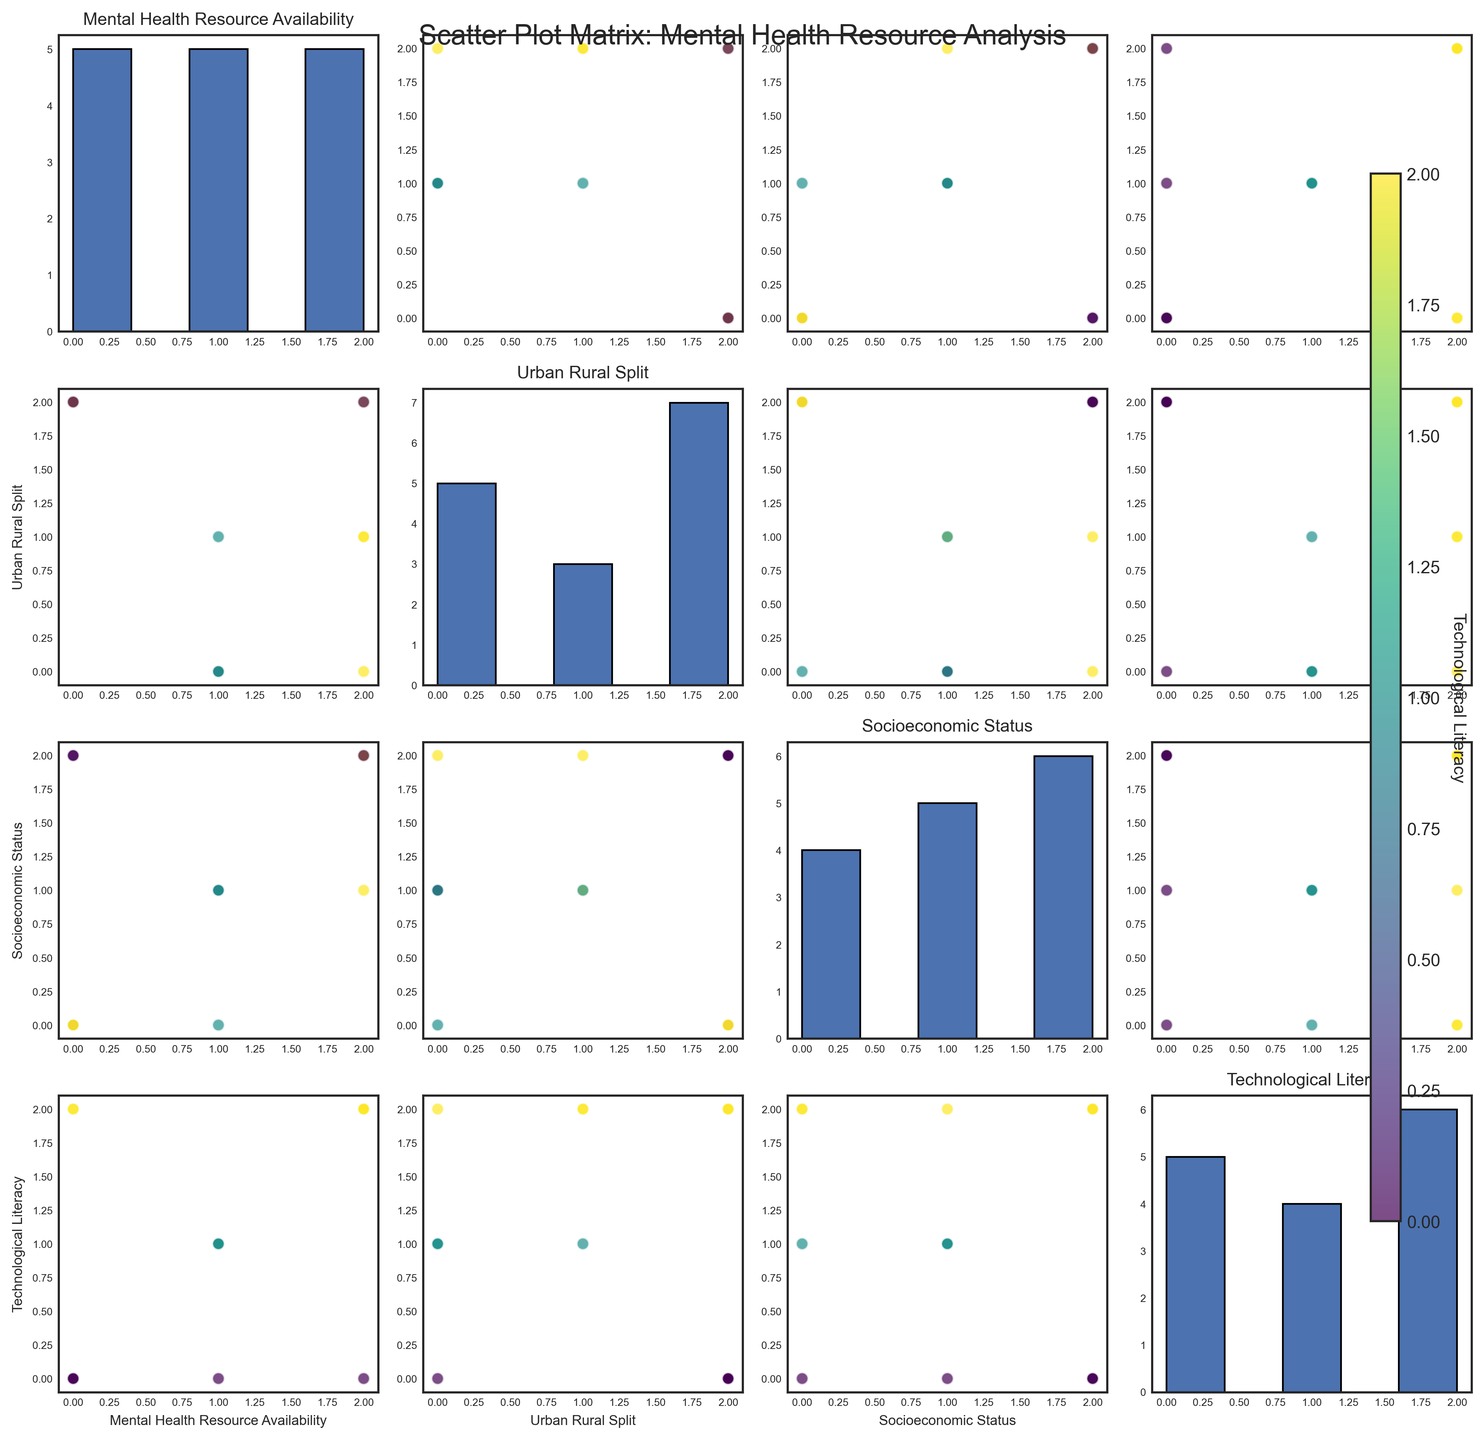what is the main title of the figure about mental health? Look at the top of the figure; the main title is usually prominently placed there. It reads "Scatter Plot Matrix: Mental Health Resource Analysis."
Answer: Scatter Plot Matrix: Mental Health Resource Analysis how many data points are present in each scatter plot? Count the dots in any one of the scatter plots in the matrix. The number of data points remains consistent across all scatter plots. There are 15 data points.
Answer: 15 which variable appears on both the x and y axes in one of the histograms? In a SPLOM, histograms appear where a variable is plotted against itself. Look for where the x and y axes share the same label. "Mental Health Resource Availability" is one such variable.
Answer: Mental Health Resource Availability is there a clearer trend between socioeconomic status and technological literacy? Compare the scatter plots that feature "Socioeconomic Status" against "Technological Literacy." While the color gradient (which represents technological literacy) shows some variation, there is a noticeable pattern of higher socioeconomic status clustering with higher technological literacy.
Answer: Yes are urban areas correlated with higher levels of mental health resources compared to rural areas? Examine the scatter plots involving "Urban Rural Split" and "Mental Health Resource Availability." Urban points (those colored uniquely for clarity) tend to cluster higher on the availability axis, indicating a stronger correlation.
Answer: Yes what is the distribution shape for technological literacy as depicted in the histogram? Focus on the histogram that features "Technological Literacy" on both axes. Noticing the bars' heights and spread, the distribution appears almost uniform, with slight variations among the bins.
Answer: Uniform in which type of area (urban, rural, or semi-urban) is medium technological literacy most frequently observed? Look at the scatter plot axes where "Urban Rural Split" intersects with "Technological Literacy." Noticing the clusters, medium technological literacy is often seen in urban and semi-urban areas.
Answer: Urban and semi-urban is there a noticeable trend between mental health resource availability and socioeconomic status? Check the plots combining "Mental_Health_Resource_Availability" and "Socioeconomic_Status." Higher resource availability dots often coincide with higher socioeconomic status, suggesting a correlation.
Answer: Yes how does socioeconomic status compare between rural and urban areas? Observe scatter plots featuring both "Urban_Rural_Split" and "Socioeconomic_Status." Rural areas frequently display lower socioeconomic status compared to urban areas, which show higher status levels.
Answer: Rural areas often have lower socioeconomic status compared to urban areas 